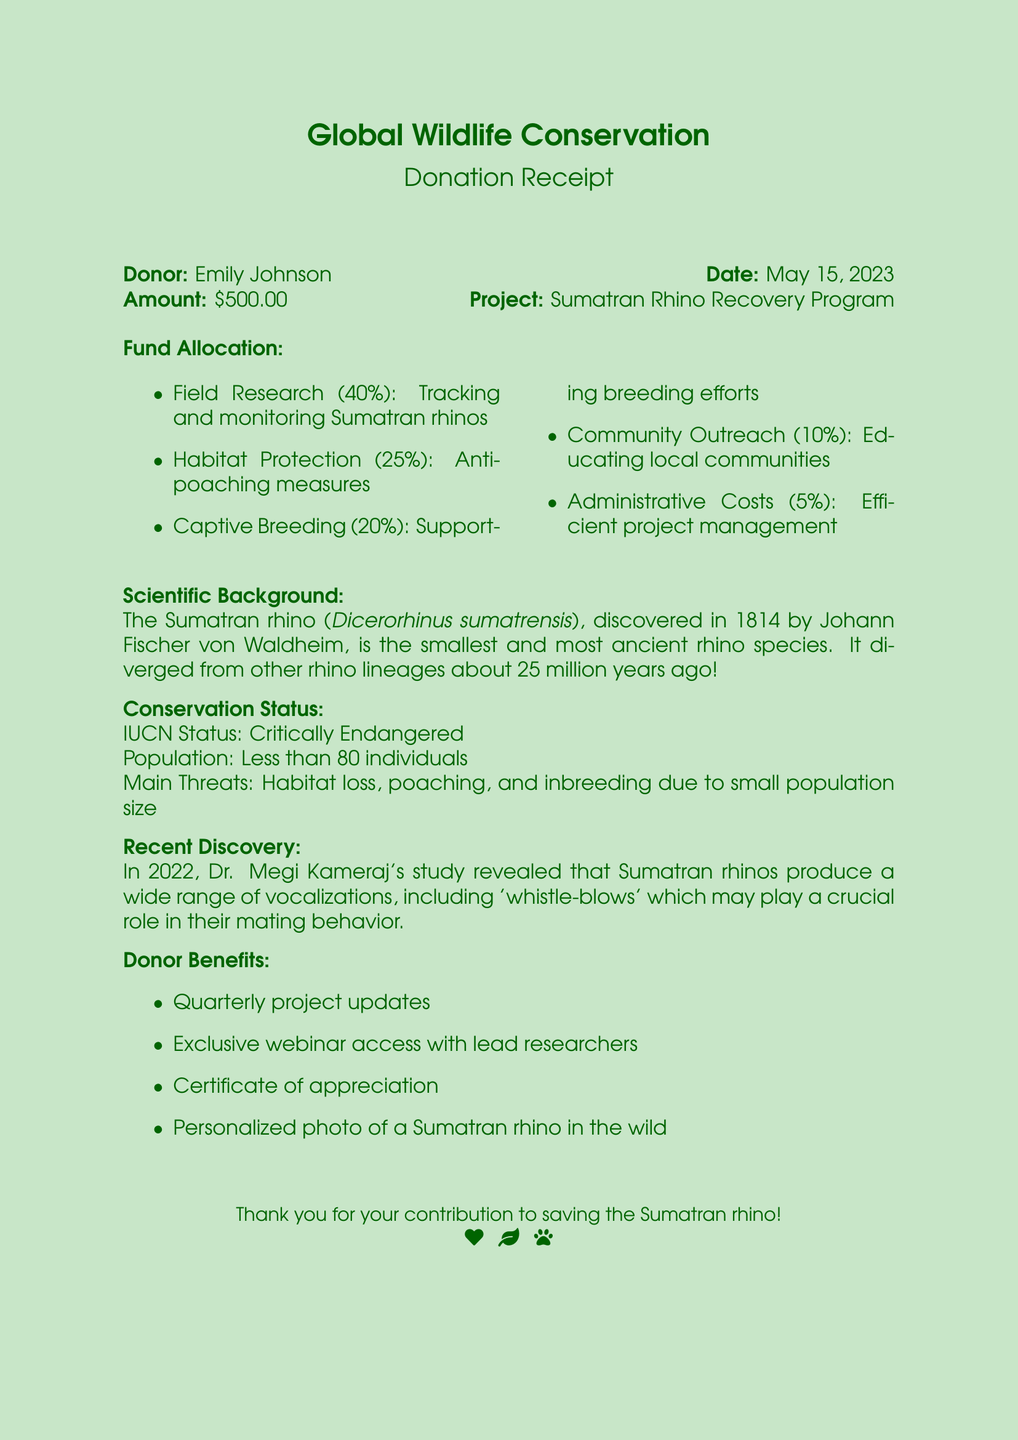What is the name of the organization? The organization mentioned in the document is Global Wildlife Conservation.
Answer: Global Wildlife Conservation Who is the donor? The document identifies Emily Johnson as the donor of the contribution.
Answer: Emily Johnson What is the total donation amount? The donation amount listed in the document is $500.00.
Answer: $500.00 What date was the donation made? The donation was made on May 15, 2023, as specified in the document.
Answer: May 15, 2023 What percentage of the funds is allocated to Field Research? Field Research is allocated 40% of the donation amount.
Answer: 40% What is the IUCN status of the Sumatran rhino? The document indicates that the IUCN status is Critically Endangered.
Answer: Critically Endangered What year was the Sumatran rhino discovered? The Sumatran rhino was discovered in the year 1814.
Answer: 1814 Who discovered the Sumatran rhino? Johann Fischer von Waldheim is identified as the discoverer of the Sumatran rhino.
Answer: Johann Fischer von Waldheim What is one donor benefit mentioned in the document? The document lists several benefits; one of them is quarterly project updates.
Answer: Quarterly project updates 